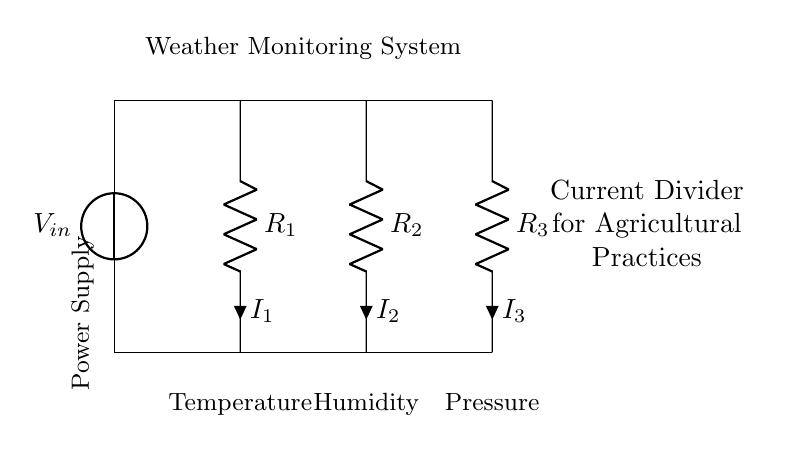What is the input voltage of this circuit? The circuit diagram shows a voltage source labeled as V_in, which indicates the input voltage. The exact value is not specified but is typically determined in the context of the system.
Answer: V_in What are the resistances connected in this current divider? The circuit has three resistors labeled R_1, R_2, and R_3. Each resistor represents a path for the current to flow through in the current divider configuration.
Answer: R_1, R_2, R_3 What is the purpose of the current divider in this system? The current divider is used to split the total current into multiple paths, allowing different sensors to measure parameters like temperature, humidity, and pressure simultaneously without affecting each other's readings.
Answer: To measure multiple parameters What is the total current flowing through the power supply? The total current provided by the power supply is the sum of the individual currents (I_1, I_2, I_3) flowing through the resistors, which obeys Kirchhoff's current law. The calculation would require specific resistor values and input voltage.
Answer: I_1 + I_2 + I_3 Which sensor measures humidity in the system? The resistor R_2 is connected to the humidity sensor according to the labels shown in the circuit diagram. This sensor is utilized to monitor the moisture content in the air, which is crucial for agricultural practices.
Answer: R_2 If R_1, R_2, and R_3 are equal, what is the current through each resistor? In a current divider with equal resistances, the current is equally divided among the resistors. Therefore, if the total current is known, each resistor would receive one-third of the total current.
Answer: Total current divided by 3 